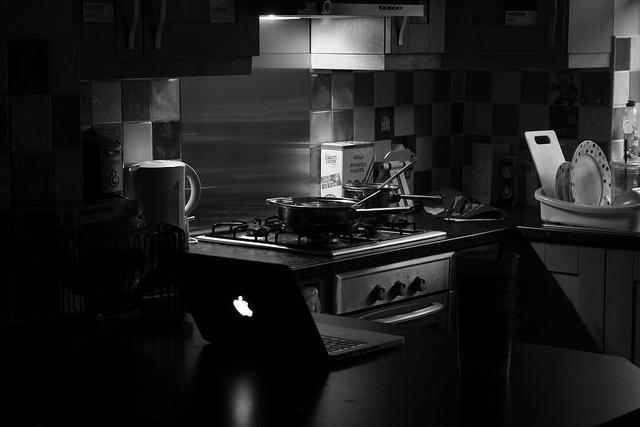Is there a towel hanging on the equipment?
Be succinct. No. What brand is the laptop?
Keep it brief. Apple. Is the wall black?
Write a very short answer. No. Is the cutting board dirty?
Answer briefly. No. Are there any humans?
Answer briefly. No. How many knobs are on the stove?
Write a very short answer. 3. Does that look like a public restroom?
Be succinct. No. Are the lights on?
Keep it brief. No. What kind of container is on the ledge?
Give a very brief answer. Pot. 